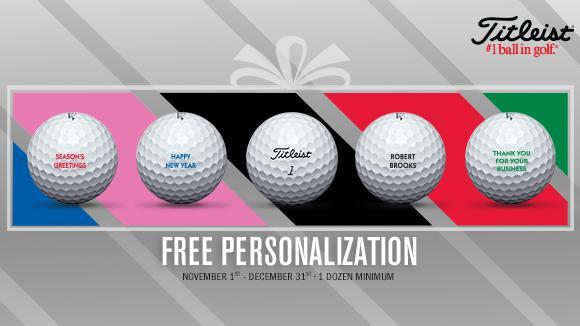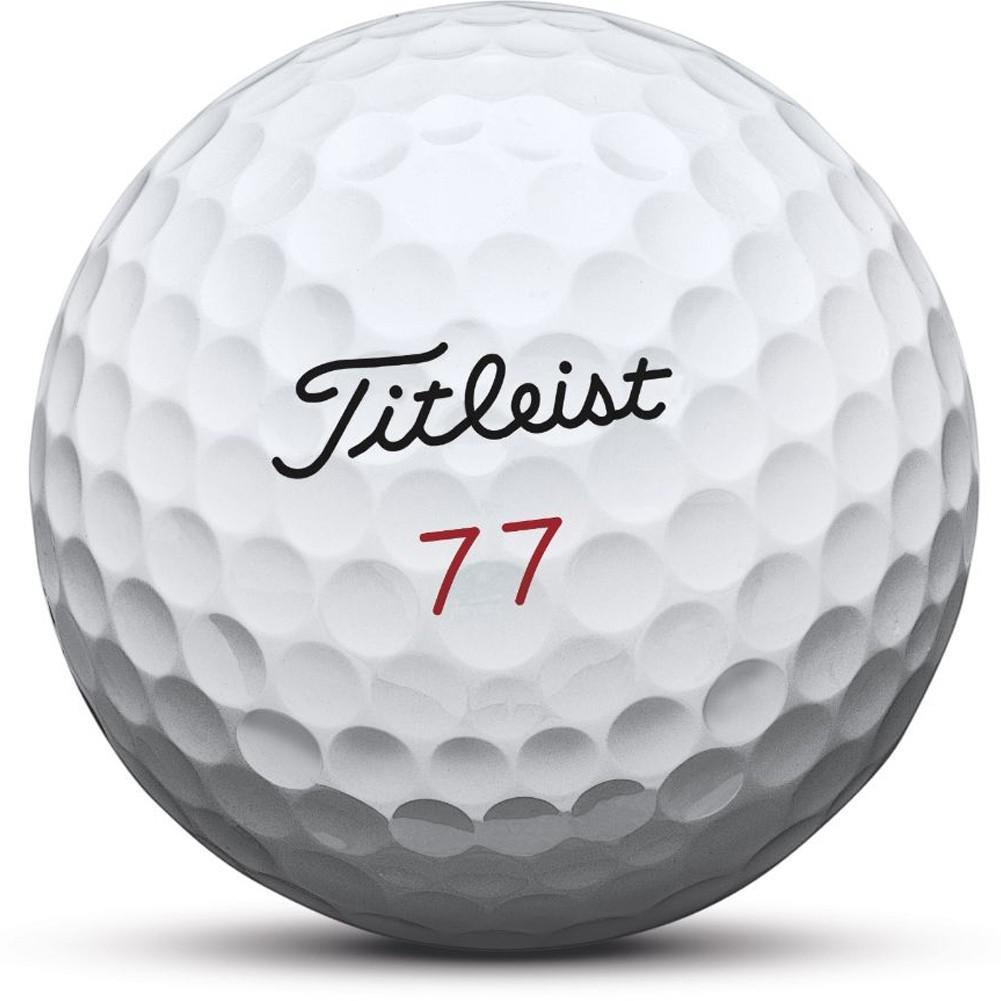The first image is the image on the left, the second image is the image on the right. Assess this claim about the two images: "The combined images contain exactly six white golf balls.". Correct or not? Answer yes or no. Yes. The first image is the image on the left, the second image is the image on the right. Evaluate the accuracy of this statement regarding the images: "The left and right image contains a total of six golf balls.". Is it true? Answer yes or no. Yes. 